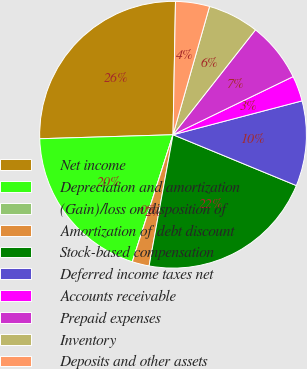Convert chart. <chart><loc_0><loc_0><loc_500><loc_500><pie_chart><fcel>Net income<fcel>Depreciation and amortization<fcel>(Gain)/loss on disposition of<fcel>Amortization of debt discount<fcel>Stock-based compensation<fcel>Deferred income taxes net<fcel>Accounts receivable<fcel>Prepaid expenses<fcel>Inventory<fcel>Deposits and other assets<nl><fcel>25.77%<fcel>19.59%<fcel>0.0%<fcel>2.06%<fcel>21.65%<fcel>10.31%<fcel>3.09%<fcel>7.22%<fcel>6.19%<fcel>4.12%<nl></chart> 